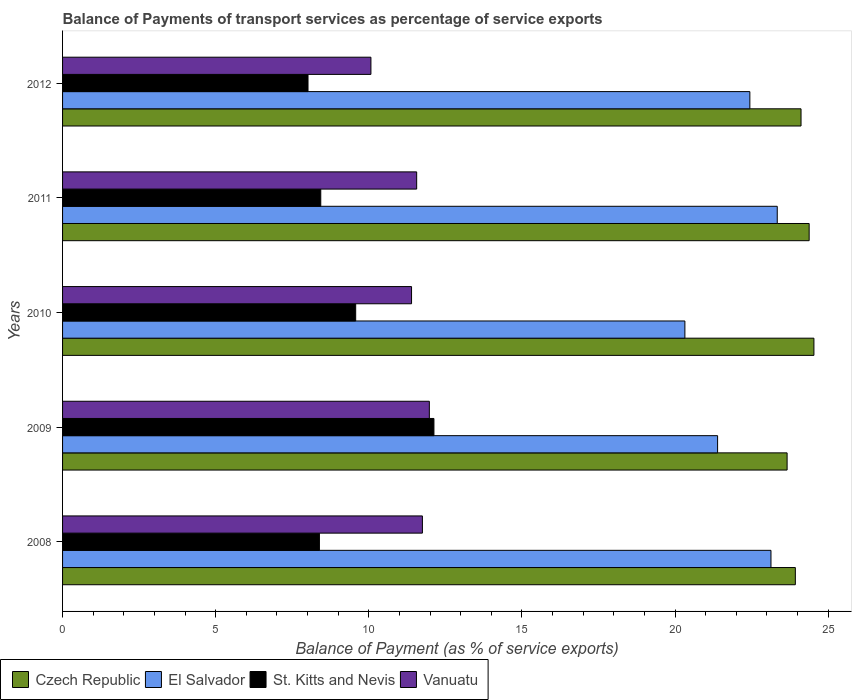How many different coloured bars are there?
Ensure brevity in your answer.  4. How many groups of bars are there?
Provide a short and direct response. 5. Are the number of bars per tick equal to the number of legend labels?
Your answer should be compact. Yes. How many bars are there on the 5th tick from the top?
Your answer should be very brief. 4. How many bars are there on the 1st tick from the bottom?
Provide a short and direct response. 4. In how many cases, is the number of bars for a given year not equal to the number of legend labels?
Provide a succinct answer. 0. What is the balance of payments of transport services in Czech Republic in 2011?
Your answer should be very brief. 24.38. Across all years, what is the maximum balance of payments of transport services in St. Kitts and Nevis?
Offer a terse response. 12.13. Across all years, what is the minimum balance of payments of transport services in Vanuatu?
Your answer should be compact. 10.07. In which year was the balance of payments of transport services in Vanuatu maximum?
Provide a succinct answer. 2009. In which year was the balance of payments of transport services in Czech Republic minimum?
Offer a very short reply. 2009. What is the total balance of payments of transport services in Vanuatu in the graph?
Keep it short and to the point. 56.76. What is the difference between the balance of payments of transport services in El Salvador in 2010 and that in 2012?
Provide a succinct answer. -2.12. What is the difference between the balance of payments of transport services in St. Kitts and Nevis in 2010 and the balance of payments of transport services in Czech Republic in 2012?
Keep it short and to the point. -14.54. What is the average balance of payments of transport services in Vanuatu per year?
Provide a short and direct response. 11.35. In the year 2008, what is the difference between the balance of payments of transport services in El Salvador and balance of payments of transport services in Czech Republic?
Provide a short and direct response. -0.8. What is the ratio of the balance of payments of transport services in St. Kitts and Nevis in 2009 to that in 2012?
Give a very brief answer. 1.51. What is the difference between the highest and the second highest balance of payments of transport services in St. Kitts and Nevis?
Keep it short and to the point. 2.56. What is the difference between the highest and the lowest balance of payments of transport services in Vanuatu?
Make the answer very short. 1.91. Is the sum of the balance of payments of transport services in El Salvador in 2009 and 2011 greater than the maximum balance of payments of transport services in St. Kitts and Nevis across all years?
Provide a short and direct response. Yes. Is it the case that in every year, the sum of the balance of payments of transport services in Czech Republic and balance of payments of transport services in Vanuatu is greater than the sum of balance of payments of transport services in St. Kitts and Nevis and balance of payments of transport services in El Salvador?
Provide a succinct answer. No. What does the 4th bar from the top in 2011 represents?
Your answer should be compact. Czech Republic. What does the 3rd bar from the bottom in 2008 represents?
Offer a terse response. St. Kitts and Nevis. How many bars are there?
Give a very brief answer. 20. Are all the bars in the graph horizontal?
Offer a terse response. Yes. Are the values on the major ticks of X-axis written in scientific E-notation?
Provide a succinct answer. No. Does the graph contain grids?
Provide a short and direct response. No. How many legend labels are there?
Provide a short and direct response. 4. What is the title of the graph?
Your response must be concise. Balance of Payments of transport services as percentage of service exports. Does "Mauritius" appear as one of the legend labels in the graph?
Keep it short and to the point. No. What is the label or title of the X-axis?
Provide a short and direct response. Balance of Payment (as % of service exports). What is the label or title of the Y-axis?
Provide a succinct answer. Years. What is the Balance of Payment (as % of service exports) in Czech Republic in 2008?
Give a very brief answer. 23.93. What is the Balance of Payment (as % of service exports) in El Salvador in 2008?
Offer a terse response. 23.13. What is the Balance of Payment (as % of service exports) in St. Kitts and Nevis in 2008?
Offer a very short reply. 8.39. What is the Balance of Payment (as % of service exports) of Vanuatu in 2008?
Provide a succinct answer. 11.75. What is the Balance of Payment (as % of service exports) of Czech Republic in 2009?
Offer a terse response. 23.66. What is the Balance of Payment (as % of service exports) in El Salvador in 2009?
Keep it short and to the point. 21.39. What is the Balance of Payment (as % of service exports) of St. Kitts and Nevis in 2009?
Provide a short and direct response. 12.13. What is the Balance of Payment (as % of service exports) of Vanuatu in 2009?
Make the answer very short. 11.98. What is the Balance of Payment (as % of service exports) in Czech Republic in 2010?
Your answer should be very brief. 24.54. What is the Balance of Payment (as % of service exports) in El Salvador in 2010?
Your response must be concise. 20.32. What is the Balance of Payment (as % of service exports) in St. Kitts and Nevis in 2010?
Keep it short and to the point. 9.57. What is the Balance of Payment (as % of service exports) of Vanuatu in 2010?
Keep it short and to the point. 11.4. What is the Balance of Payment (as % of service exports) in Czech Republic in 2011?
Keep it short and to the point. 24.38. What is the Balance of Payment (as % of service exports) of El Salvador in 2011?
Make the answer very short. 23.34. What is the Balance of Payment (as % of service exports) of St. Kitts and Nevis in 2011?
Provide a short and direct response. 8.43. What is the Balance of Payment (as % of service exports) of Vanuatu in 2011?
Keep it short and to the point. 11.56. What is the Balance of Payment (as % of service exports) of Czech Republic in 2012?
Offer a terse response. 24.12. What is the Balance of Payment (as % of service exports) in El Salvador in 2012?
Ensure brevity in your answer.  22.44. What is the Balance of Payment (as % of service exports) in St. Kitts and Nevis in 2012?
Provide a short and direct response. 8.02. What is the Balance of Payment (as % of service exports) of Vanuatu in 2012?
Offer a very short reply. 10.07. Across all years, what is the maximum Balance of Payment (as % of service exports) of Czech Republic?
Give a very brief answer. 24.54. Across all years, what is the maximum Balance of Payment (as % of service exports) of El Salvador?
Offer a very short reply. 23.34. Across all years, what is the maximum Balance of Payment (as % of service exports) in St. Kitts and Nevis?
Your answer should be very brief. 12.13. Across all years, what is the maximum Balance of Payment (as % of service exports) in Vanuatu?
Offer a terse response. 11.98. Across all years, what is the minimum Balance of Payment (as % of service exports) in Czech Republic?
Offer a very short reply. 23.66. Across all years, what is the minimum Balance of Payment (as % of service exports) in El Salvador?
Your answer should be very brief. 20.32. Across all years, what is the minimum Balance of Payment (as % of service exports) of St. Kitts and Nevis?
Your response must be concise. 8.02. Across all years, what is the minimum Balance of Payment (as % of service exports) in Vanuatu?
Your answer should be very brief. 10.07. What is the total Balance of Payment (as % of service exports) in Czech Republic in the graph?
Keep it short and to the point. 120.62. What is the total Balance of Payment (as % of service exports) of El Salvador in the graph?
Ensure brevity in your answer.  110.63. What is the total Balance of Payment (as % of service exports) of St. Kitts and Nevis in the graph?
Offer a very short reply. 46.53. What is the total Balance of Payment (as % of service exports) of Vanuatu in the graph?
Give a very brief answer. 56.76. What is the difference between the Balance of Payment (as % of service exports) in Czech Republic in 2008 and that in 2009?
Offer a terse response. 0.27. What is the difference between the Balance of Payment (as % of service exports) of El Salvador in 2008 and that in 2009?
Your answer should be compact. 1.74. What is the difference between the Balance of Payment (as % of service exports) in St. Kitts and Nevis in 2008 and that in 2009?
Your response must be concise. -3.74. What is the difference between the Balance of Payment (as % of service exports) of Vanuatu in 2008 and that in 2009?
Offer a terse response. -0.23. What is the difference between the Balance of Payment (as % of service exports) of Czech Republic in 2008 and that in 2010?
Keep it short and to the point. -0.61. What is the difference between the Balance of Payment (as % of service exports) of El Salvador in 2008 and that in 2010?
Keep it short and to the point. 2.81. What is the difference between the Balance of Payment (as % of service exports) in St. Kitts and Nevis in 2008 and that in 2010?
Give a very brief answer. -1.18. What is the difference between the Balance of Payment (as % of service exports) in Vanuatu in 2008 and that in 2010?
Your response must be concise. 0.35. What is the difference between the Balance of Payment (as % of service exports) in Czech Republic in 2008 and that in 2011?
Give a very brief answer. -0.45. What is the difference between the Balance of Payment (as % of service exports) of El Salvador in 2008 and that in 2011?
Ensure brevity in your answer.  -0.2. What is the difference between the Balance of Payment (as % of service exports) of St. Kitts and Nevis in 2008 and that in 2011?
Offer a terse response. -0.04. What is the difference between the Balance of Payment (as % of service exports) of Vanuatu in 2008 and that in 2011?
Your answer should be compact. 0.19. What is the difference between the Balance of Payment (as % of service exports) in Czech Republic in 2008 and that in 2012?
Ensure brevity in your answer.  -0.19. What is the difference between the Balance of Payment (as % of service exports) of El Salvador in 2008 and that in 2012?
Keep it short and to the point. 0.69. What is the difference between the Balance of Payment (as % of service exports) of St. Kitts and Nevis in 2008 and that in 2012?
Make the answer very short. 0.37. What is the difference between the Balance of Payment (as % of service exports) in Vanuatu in 2008 and that in 2012?
Offer a very short reply. 1.68. What is the difference between the Balance of Payment (as % of service exports) in Czech Republic in 2009 and that in 2010?
Your answer should be compact. -0.88. What is the difference between the Balance of Payment (as % of service exports) in El Salvador in 2009 and that in 2010?
Provide a short and direct response. 1.07. What is the difference between the Balance of Payment (as % of service exports) of St. Kitts and Nevis in 2009 and that in 2010?
Provide a short and direct response. 2.56. What is the difference between the Balance of Payment (as % of service exports) in Vanuatu in 2009 and that in 2010?
Give a very brief answer. 0.58. What is the difference between the Balance of Payment (as % of service exports) of Czech Republic in 2009 and that in 2011?
Offer a terse response. -0.72. What is the difference between the Balance of Payment (as % of service exports) in El Salvador in 2009 and that in 2011?
Ensure brevity in your answer.  -1.95. What is the difference between the Balance of Payment (as % of service exports) of St. Kitts and Nevis in 2009 and that in 2011?
Provide a succinct answer. 3.7. What is the difference between the Balance of Payment (as % of service exports) of Vanuatu in 2009 and that in 2011?
Offer a terse response. 0.41. What is the difference between the Balance of Payment (as % of service exports) of Czech Republic in 2009 and that in 2012?
Your response must be concise. -0.45. What is the difference between the Balance of Payment (as % of service exports) of El Salvador in 2009 and that in 2012?
Offer a terse response. -1.05. What is the difference between the Balance of Payment (as % of service exports) of St. Kitts and Nevis in 2009 and that in 2012?
Provide a short and direct response. 4.11. What is the difference between the Balance of Payment (as % of service exports) of Vanuatu in 2009 and that in 2012?
Provide a short and direct response. 1.91. What is the difference between the Balance of Payment (as % of service exports) in Czech Republic in 2010 and that in 2011?
Offer a terse response. 0.16. What is the difference between the Balance of Payment (as % of service exports) of El Salvador in 2010 and that in 2011?
Keep it short and to the point. -3.02. What is the difference between the Balance of Payment (as % of service exports) in St. Kitts and Nevis in 2010 and that in 2011?
Give a very brief answer. 1.14. What is the difference between the Balance of Payment (as % of service exports) in Vanuatu in 2010 and that in 2011?
Provide a short and direct response. -0.17. What is the difference between the Balance of Payment (as % of service exports) in Czech Republic in 2010 and that in 2012?
Provide a short and direct response. 0.42. What is the difference between the Balance of Payment (as % of service exports) of El Salvador in 2010 and that in 2012?
Keep it short and to the point. -2.12. What is the difference between the Balance of Payment (as % of service exports) of St. Kitts and Nevis in 2010 and that in 2012?
Your answer should be very brief. 1.56. What is the difference between the Balance of Payment (as % of service exports) in Vanuatu in 2010 and that in 2012?
Give a very brief answer. 1.33. What is the difference between the Balance of Payment (as % of service exports) in Czech Republic in 2011 and that in 2012?
Your response must be concise. 0.27. What is the difference between the Balance of Payment (as % of service exports) in El Salvador in 2011 and that in 2012?
Your answer should be compact. 0.89. What is the difference between the Balance of Payment (as % of service exports) in St. Kitts and Nevis in 2011 and that in 2012?
Your response must be concise. 0.42. What is the difference between the Balance of Payment (as % of service exports) of Vanuatu in 2011 and that in 2012?
Your response must be concise. 1.49. What is the difference between the Balance of Payment (as % of service exports) in Czech Republic in 2008 and the Balance of Payment (as % of service exports) in El Salvador in 2009?
Your response must be concise. 2.54. What is the difference between the Balance of Payment (as % of service exports) in Czech Republic in 2008 and the Balance of Payment (as % of service exports) in St. Kitts and Nevis in 2009?
Offer a very short reply. 11.8. What is the difference between the Balance of Payment (as % of service exports) of Czech Republic in 2008 and the Balance of Payment (as % of service exports) of Vanuatu in 2009?
Offer a very short reply. 11.95. What is the difference between the Balance of Payment (as % of service exports) in El Salvador in 2008 and the Balance of Payment (as % of service exports) in St. Kitts and Nevis in 2009?
Give a very brief answer. 11.01. What is the difference between the Balance of Payment (as % of service exports) in El Salvador in 2008 and the Balance of Payment (as % of service exports) in Vanuatu in 2009?
Offer a very short reply. 11.16. What is the difference between the Balance of Payment (as % of service exports) of St. Kitts and Nevis in 2008 and the Balance of Payment (as % of service exports) of Vanuatu in 2009?
Offer a very short reply. -3.59. What is the difference between the Balance of Payment (as % of service exports) of Czech Republic in 2008 and the Balance of Payment (as % of service exports) of El Salvador in 2010?
Offer a very short reply. 3.61. What is the difference between the Balance of Payment (as % of service exports) of Czech Republic in 2008 and the Balance of Payment (as % of service exports) of St. Kitts and Nevis in 2010?
Provide a succinct answer. 14.36. What is the difference between the Balance of Payment (as % of service exports) in Czech Republic in 2008 and the Balance of Payment (as % of service exports) in Vanuatu in 2010?
Offer a terse response. 12.53. What is the difference between the Balance of Payment (as % of service exports) of El Salvador in 2008 and the Balance of Payment (as % of service exports) of St. Kitts and Nevis in 2010?
Give a very brief answer. 13.56. What is the difference between the Balance of Payment (as % of service exports) in El Salvador in 2008 and the Balance of Payment (as % of service exports) in Vanuatu in 2010?
Make the answer very short. 11.74. What is the difference between the Balance of Payment (as % of service exports) of St. Kitts and Nevis in 2008 and the Balance of Payment (as % of service exports) of Vanuatu in 2010?
Keep it short and to the point. -3.01. What is the difference between the Balance of Payment (as % of service exports) in Czech Republic in 2008 and the Balance of Payment (as % of service exports) in El Salvador in 2011?
Offer a very short reply. 0.59. What is the difference between the Balance of Payment (as % of service exports) in Czech Republic in 2008 and the Balance of Payment (as % of service exports) in St. Kitts and Nevis in 2011?
Give a very brief answer. 15.5. What is the difference between the Balance of Payment (as % of service exports) of Czech Republic in 2008 and the Balance of Payment (as % of service exports) of Vanuatu in 2011?
Provide a short and direct response. 12.37. What is the difference between the Balance of Payment (as % of service exports) in El Salvador in 2008 and the Balance of Payment (as % of service exports) in St. Kitts and Nevis in 2011?
Keep it short and to the point. 14.7. What is the difference between the Balance of Payment (as % of service exports) of El Salvador in 2008 and the Balance of Payment (as % of service exports) of Vanuatu in 2011?
Give a very brief answer. 11.57. What is the difference between the Balance of Payment (as % of service exports) of St. Kitts and Nevis in 2008 and the Balance of Payment (as % of service exports) of Vanuatu in 2011?
Your answer should be compact. -3.18. What is the difference between the Balance of Payment (as % of service exports) of Czech Republic in 2008 and the Balance of Payment (as % of service exports) of El Salvador in 2012?
Your response must be concise. 1.49. What is the difference between the Balance of Payment (as % of service exports) in Czech Republic in 2008 and the Balance of Payment (as % of service exports) in St. Kitts and Nevis in 2012?
Your response must be concise. 15.91. What is the difference between the Balance of Payment (as % of service exports) in Czech Republic in 2008 and the Balance of Payment (as % of service exports) in Vanuatu in 2012?
Keep it short and to the point. 13.86. What is the difference between the Balance of Payment (as % of service exports) in El Salvador in 2008 and the Balance of Payment (as % of service exports) in St. Kitts and Nevis in 2012?
Offer a very short reply. 15.12. What is the difference between the Balance of Payment (as % of service exports) in El Salvador in 2008 and the Balance of Payment (as % of service exports) in Vanuatu in 2012?
Keep it short and to the point. 13.06. What is the difference between the Balance of Payment (as % of service exports) in St. Kitts and Nevis in 2008 and the Balance of Payment (as % of service exports) in Vanuatu in 2012?
Ensure brevity in your answer.  -1.68. What is the difference between the Balance of Payment (as % of service exports) of Czech Republic in 2009 and the Balance of Payment (as % of service exports) of El Salvador in 2010?
Keep it short and to the point. 3.34. What is the difference between the Balance of Payment (as % of service exports) of Czech Republic in 2009 and the Balance of Payment (as % of service exports) of St. Kitts and Nevis in 2010?
Your response must be concise. 14.09. What is the difference between the Balance of Payment (as % of service exports) of Czech Republic in 2009 and the Balance of Payment (as % of service exports) of Vanuatu in 2010?
Provide a succinct answer. 12.26. What is the difference between the Balance of Payment (as % of service exports) of El Salvador in 2009 and the Balance of Payment (as % of service exports) of St. Kitts and Nevis in 2010?
Ensure brevity in your answer.  11.82. What is the difference between the Balance of Payment (as % of service exports) in El Salvador in 2009 and the Balance of Payment (as % of service exports) in Vanuatu in 2010?
Provide a succinct answer. 9.99. What is the difference between the Balance of Payment (as % of service exports) of St. Kitts and Nevis in 2009 and the Balance of Payment (as % of service exports) of Vanuatu in 2010?
Your answer should be compact. 0.73. What is the difference between the Balance of Payment (as % of service exports) in Czech Republic in 2009 and the Balance of Payment (as % of service exports) in El Salvador in 2011?
Your response must be concise. 0.32. What is the difference between the Balance of Payment (as % of service exports) in Czech Republic in 2009 and the Balance of Payment (as % of service exports) in St. Kitts and Nevis in 2011?
Provide a short and direct response. 15.23. What is the difference between the Balance of Payment (as % of service exports) in Czech Republic in 2009 and the Balance of Payment (as % of service exports) in Vanuatu in 2011?
Make the answer very short. 12.1. What is the difference between the Balance of Payment (as % of service exports) in El Salvador in 2009 and the Balance of Payment (as % of service exports) in St. Kitts and Nevis in 2011?
Provide a succinct answer. 12.96. What is the difference between the Balance of Payment (as % of service exports) of El Salvador in 2009 and the Balance of Payment (as % of service exports) of Vanuatu in 2011?
Make the answer very short. 9.83. What is the difference between the Balance of Payment (as % of service exports) in St. Kitts and Nevis in 2009 and the Balance of Payment (as % of service exports) in Vanuatu in 2011?
Ensure brevity in your answer.  0.56. What is the difference between the Balance of Payment (as % of service exports) of Czech Republic in 2009 and the Balance of Payment (as % of service exports) of El Salvador in 2012?
Give a very brief answer. 1.22. What is the difference between the Balance of Payment (as % of service exports) of Czech Republic in 2009 and the Balance of Payment (as % of service exports) of St. Kitts and Nevis in 2012?
Your answer should be compact. 15.65. What is the difference between the Balance of Payment (as % of service exports) of Czech Republic in 2009 and the Balance of Payment (as % of service exports) of Vanuatu in 2012?
Provide a short and direct response. 13.59. What is the difference between the Balance of Payment (as % of service exports) in El Salvador in 2009 and the Balance of Payment (as % of service exports) in St. Kitts and Nevis in 2012?
Your answer should be very brief. 13.38. What is the difference between the Balance of Payment (as % of service exports) in El Salvador in 2009 and the Balance of Payment (as % of service exports) in Vanuatu in 2012?
Give a very brief answer. 11.32. What is the difference between the Balance of Payment (as % of service exports) in St. Kitts and Nevis in 2009 and the Balance of Payment (as % of service exports) in Vanuatu in 2012?
Give a very brief answer. 2.06. What is the difference between the Balance of Payment (as % of service exports) of Czech Republic in 2010 and the Balance of Payment (as % of service exports) of El Salvador in 2011?
Your answer should be very brief. 1.2. What is the difference between the Balance of Payment (as % of service exports) in Czech Republic in 2010 and the Balance of Payment (as % of service exports) in St. Kitts and Nevis in 2011?
Offer a very short reply. 16.1. What is the difference between the Balance of Payment (as % of service exports) in Czech Republic in 2010 and the Balance of Payment (as % of service exports) in Vanuatu in 2011?
Give a very brief answer. 12.97. What is the difference between the Balance of Payment (as % of service exports) of El Salvador in 2010 and the Balance of Payment (as % of service exports) of St. Kitts and Nevis in 2011?
Offer a very short reply. 11.89. What is the difference between the Balance of Payment (as % of service exports) of El Salvador in 2010 and the Balance of Payment (as % of service exports) of Vanuatu in 2011?
Your response must be concise. 8.76. What is the difference between the Balance of Payment (as % of service exports) in St. Kitts and Nevis in 2010 and the Balance of Payment (as % of service exports) in Vanuatu in 2011?
Provide a succinct answer. -1.99. What is the difference between the Balance of Payment (as % of service exports) in Czech Republic in 2010 and the Balance of Payment (as % of service exports) in El Salvador in 2012?
Give a very brief answer. 2.09. What is the difference between the Balance of Payment (as % of service exports) in Czech Republic in 2010 and the Balance of Payment (as % of service exports) in St. Kitts and Nevis in 2012?
Make the answer very short. 16.52. What is the difference between the Balance of Payment (as % of service exports) in Czech Republic in 2010 and the Balance of Payment (as % of service exports) in Vanuatu in 2012?
Give a very brief answer. 14.47. What is the difference between the Balance of Payment (as % of service exports) in El Salvador in 2010 and the Balance of Payment (as % of service exports) in St. Kitts and Nevis in 2012?
Offer a very short reply. 12.31. What is the difference between the Balance of Payment (as % of service exports) of El Salvador in 2010 and the Balance of Payment (as % of service exports) of Vanuatu in 2012?
Keep it short and to the point. 10.25. What is the difference between the Balance of Payment (as % of service exports) of St. Kitts and Nevis in 2010 and the Balance of Payment (as % of service exports) of Vanuatu in 2012?
Your answer should be very brief. -0.5. What is the difference between the Balance of Payment (as % of service exports) in Czech Republic in 2011 and the Balance of Payment (as % of service exports) in El Salvador in 2012?
Ensure brevity in your answer.  1.94. What is the difference between the Balance of Payment (as % of service exports) of Czech Republic in 2011 and the Balance of Payment (as % of service exports) of St. Kitts and Nevis in 2012?
Your answer should be compact. 16.37. What is the difference between the Balance of Payment (as % of service exports) of Czech Republic in 2011 and the Balance of Payment (as % of service exports) of Vanuatu in 2012?
Ensure brevity in your answer.  14.31. What is the difference between the Balance of Payment (as % of service exports) in El Salvador in 2011 and the Balance of Payment (as % of service exports) in St. Kitts and Nevis in 2012?
Offer a terse response. 15.32. What is the difference between the Balance of Payment (as % of service exports) in El Salvador in 2011 and the Balance of Payment (as % of service exports) in Vanuatu in 2012?
Make the answer very short. 13.27. What is the difference between the Balance of Payment (as % of service exports) in St. Kitts and Nevis in 2011 and the Balance of Payment (as % of service exports) in Vanuatu in 2012?
Offer a terse response. -1.64. What is the average Balance of Payment (as % of service exports) in Czech Republic per year?
Your answer should be very brief. 24.12. What is the average Balance of Payment (as % of service exports) in El Salvador per year?
Your answer should be compact. 22.13. What is the average Balance of Payment (as % of service exports) of St. Kitts and Nevis per year?
Offer a very short reply. 9.31. What is the average Balance of Payment (as % of service exports) in Vanuatu per year?
Ensure brevity in your answer.  11.35. In the year 2008, what is the difference between the Balance of Payment (as % of service exports) in Czech Republic and Balance of Payment (as % of service exports) in El Salvador?
Your answer should be compact. 0.8. In the year 2008, what is the difference between the Balance of Payment (as % of service exports) in Czech Republic and Balance of Payment (as % of service exports) in St. Kitts and Nevis?
Offer a terse response. 15.54. In the year 2008, what is the difference between the Balance of Payment (as % of service exports) of Czech Republic and Balance of Payment (as % of service exports) of Vanuatu?
Give a very brief answer. 12.18. In the year 2008, what is the difference between the Balance of Payment (as % of service exports) of El Salvador and Balance of Payment (as % of service exports) of St. Kitts and Nevis?
Provide a succinct answer. 14.75. In the year 2008, what is the difference between the Balance of Payment (as % of service exports) of El Salvador and Balance of Payment (as % of service exports) of Vanuatu?
Your answer should be very brief. 11.38. In the year 2008, what is the difference between the Balance of Payment (as % of service exports) of St. Kitts and Nevis and Balance of Payment (as % of service exports) of Vanuatu?
Your answer should be very brief. -3.36. In the year 2009, what is the difference between the Balance of Payment (as % of service exports) of Czech Republic and Balance of Payment (as % of service exports) of El Salvador?
Your answer should be very brief. 2.27. In the year 2009, what is the difference between the Balance of Payment (as % of service exports) in Czech Republic and Balance of Payment (as % of service exports) in St. Kitts and Nevis?
Give a very brief answer. 11.53. In the year 2009, what is the difference between the Balance of Payment (as % of service exports) in Czech Republic and Balance of Payment (as % of service exports) in Vanuatu?
Your response must be concise. 11.68. In the year 2009, what is the difference between the Balance of Payment (as % of service exports) of El Salvador and Balance of Payment (as % of service exports) of St. Kitts and Nevis?
Keep it short and to the point. 9.26. In the year 2009, what is the difference between the Balance of Payment (as % of service exports) in El Salvador and Balance of Payment (as % of service exports) in Vanuatu?
Your response must be concise. 9.41. In the year 2009, what is the difference between the Balance of Payment (as % of service exports) of St. Kitts and Nevis and Balance of Payment (as % of service exports) of Vanuatu?
Offer a terse response. 0.15. In the year 2010, what is the difference between the Balance of Payment (as % of service exports) in Czech Republic and Balance of Payment (as % of service exports) in El Salvador?
Your response must be concise. 4.21. In the year 2010, what is the difference between the Balance of Payment (as % of service exports) in Czech Republic and Balance of Payment (as % of service exports) in St. Kitts and Nevis?
Your answer should be compact. 14.96. In the year 2010, what is the difference between the Balance of Payment (as % of service exports) of Czech Republic and Balance of Payment (as % of service exports) of Vanuatu?
Ensure brevity in your answer.  13.14. In the year 2010, what is the difference between the Balance of Payment (as % of service exports) of El Salvador and Balance of Payment (as % of service exports) of St. Kitts and Nevis?
Provide a succinct answer. 10.75. In the year 2010, what is the difference between the Balance of Payment (as % of service exports) of El Salvador and Balance of Payment (as % of service exports) of Vanuatu?
Provide a short and direct response. 8.93. In the year 2010, what is the difference between the Balance of Payment (as % of service exports) in St. Kitts and Nevis and Balance of Payment (as % of service exports) in Vanuatu?
Provide a succinct answer. -1.82. In the year 2011, what is the difference between the Balance of Payment (as % of service exports) in Czech Republic and Balance of Payment (as % of service exports) in El Salvador?
Your response must be concise. 1.04. In the year 2011, what is the difference between the Balance of Payment (as % of service exports) of Czech Republic and Balance of Payment (as % of service exports) of St. Kitts and Nevis?
Your response must be concise. 15.95. In the year 2011, what is the difference between the Balance of Payment (as % of service exports) of Czech Republic and Balance of Payment (as % of service exports) of Vanuatu?
Ensure brevity in your answer.  12.82. In the year 2011, what is the difference between the Balance of Payment (as % of service exports) of El Salvador and Balance of Payment (as % of service exports) of St. Kitts and Nevis?
Offer a terse response. 14.91. In the year 2011, what is the difference between the Balance of Payment (as % of service exports) in El Salvador and Balance of Payment (as % of service exports) in Vanuatu?
Give a very brief answer. 11.78. In the year 2011, what is the difference between the Balance of Payment (as % of service exports) in St. Kitts and Nevis and Balance of Payment (as % of service exports) in Vanuatu?
Ensure brevity in your answer.  -3.13. In the year 2012, what is the difference between the Balance of Payment (as % of service exports) in Czech Republic and Balance of Payment (as % of service exports) in El Salvador?
Give a very brief answer. 1.67. In the year 2012, what is the difference between the Balance of Payment (as % of service exports) in Czech Republic and Balance of Payment (as % of service exports) in Vanuatu?
Provide a short and direct response. 14.05. In the year 2012, what is the difference between the Balance of Payment (as % of service exports) in El Salvador and Balance of Payment (as % of service exports) in St. Kitts and Nevis?
Give a very brief answer. 14.43. In the year 2012, what is the difference between the Balance of Payment (as % of service exports) in El Salvador and Balance of Payment (as % of service exports) in Vanuatu?
Provide a short and direct response. 12.37. In the year 2012, what is the difference between the Balance of Payment (as % of service exports) in St. Kitts and Nevis and Balance of Payment (as % of service exports) in Vanuatu?
Provide a succinct answer. -2.05. What is the ratio of the Balance of Payment (as % of service exports) in Czech Republic in 2008 to that in 2009?
Provide a succinct answer. 1.01. What is the ratio of the Balance of Payment (as % of service exports) in El Salvador in 2008 to that in 2009?
Your response must be concise. 1.08. What is the ratio of the Balance of Payment (as % of service exports) of St. Kitts and Nevis in 2008 to that in 2009?
Your answer should be compact. 0.69. What is the ratio of the Balance of Payment (as % of service exports) in Vanuatu in 2008 to that in 2009?
Provide a succinct answer. 0.98. What is the ratio of the Balance of Payment (as % of service exports) of Czech Republic in 2008 to that in 2010?
Provide a short and direct response. 0.98. What is the ratio of the Balance of Payment (as % of service exports) in El Salvador in 2008 to that in 2010?
Offer a very short reply. 1.14. What is the ratio of the Balance of Payment (as % of service exports) of St. Kitts and Nevis in 2008 to that in 2010?
Provide a succinct answer. 0.88. What is the ratio of the Balance of Payment (as % of service exports) in Vanuatu in 2008 to that in 2010?
Provide a short and direct response. 1.03. What is the ratio of the Balance of Payment (as % of service exports) in Czech Republic in 2008 to that in 2011?
Ensure brevity in your answer.  0.98. What is the ratio of the Balance of Payment (as % of service exports) of El Salvador in 2008 to that in 2011?
Your response must be concise. 0.99. What is the ratio of the Balance of Payment (as % of service exports) of St. Kitts and Nevis in 2008 to that in 2011?
Ensure brevity in your answer.  0.99. What is the ratio of the Balance of Payment (as % of service exports) of Vanuatu in 2008 to that in 2011?
Your answer should be compact. 1.02. What is the ratio of the Balance of Payment (as % of service exports) in El Salvador in 2008 to that in 2012?
Your response must be concise. 1.03. What is the ratio of the Balance of Payment (as % of service exports) of St. Kitts and Nevis in 2008 to that in 2012?
Ensure brevity in your answer.  1.05. What is the ratio of the Balance of Payment (as % of service exports) in Vanuatu in 2008 to that in 2012?
Keep it short and to the point. 1.17. What is the ratio of the Balance of Payment (as % of service exports) in Czech Republic in 2009 to that in 2010?
Make the answer very short. 0.96. What is the ratio of the Balance of Payment (as % of service exports) of El Salvador in 2009 to that in 2010?
Provide a succinct answer. 1.05. What is the ratio of the Balance of Payment (as % of service exports) in St. Kitts and Nevis in 2009 to that in 2010?
Ensure brevity in your answer.  1.27. What is the ratio of the Balance of Payment (as % of service exports) in Vanuatu in 2009 to that in 2010?
Offer a terse response. 1.05. What is the ratio of the Balance of Payment (as % of service exports) in Czech Republic in 2009 to that in 2011?
Make the answer very short. 0.97. What is the ratio of the Balance of Payment (as % of service exports) of El Salvador in 2009 to that in 2011?
Give a very brief answer. 0.92. What is the ratio of the Balance of Payment (as % of service exports) in St. Kitts and Nevis in 2009 to that in 2011?
Offer a terse response. 1.44. What is the ratio of the Balance of Payment (as % of service exports) of Vanuatu in 2009 to that in 2011?
Your answer should be very brief. 1.04. What is the ratio of the Balance of Payment (as % of service exports) of Czech Republic in 2009 to that in 2012?
Your response must be concise. 0.98. What is the ratio of the Balance of Payment (as % of service exports) in El Salvador in 2009 to that in 2012?
Provide a short and direct response. 0.95. What is the ratio of the Balance of Payment (as % of service exports) in St. Kitts and Nevis in 2009 to that in 2012?
Provide a succinct answer. 1.51. What is the ratio of the Balance of Payment (as % of service exports) in Vanuatu in 2009 to that in 2012?
Your response must be concise. 1.19. What is the ratio of the Balance of Payment (as % of service exports) in Czech Republic in 2010 to that in 2011?
Ensure brevity in your answer.  1.01. What is the ratio of the Balance of Payment (as % of service exports) in El Salvador in 2010 to that in 2011?
Offer a terse response. 0.87. What is the ratio of the Balance of Payment (as % of service exports) of St. Kitts and Nevis in 2010 to that in 2011?
Give a very brief answer. 1.14. What is the ratio of the Balance of Payment (as % of service exports) in Vanuatu in 2010 to that in 2011?
Provide a succinct answer. 0.99. What is the ratio of the Balance of Payment (as % of service exports) of Czech Republic in 2010 to that in 2012?
Offer a terse response. 1.02. What is the ratio of the Balance of Payment (as % of service exports) of El Salvador in 2010 to that in 2012?
Offer a terse response. 0.91. What is the ratio of the Balance of Payment (as % of service exports) of St. Kitts and Nevis in 2010 to that in 2012?
Offer a terse response. 1.19. What is the ratio of the Balance of Payment (as % of service exports) in Vanuatu in 2010 to that in 2012?
Your response must be concise. 1.13. What is the ratio of the Balance of Payment (as % of service exports) of Czech Republic in 2011 to that in 2012?
Ensure brevity in your answer.  1.01. What is the ratio of the Balance of Payment (as % of service exports) in El Salvador in 2011 to that in 2012?
Keep it short and to the point. 1.04. What is the ratio of the Balance of Payment (as % of service exports) in St. Kitts and Nevis in 2011 to that in 2012?
Provide a short and direct response. 1.05. What is the ratio of the Balance of Payment (as % of service exports) of Vanuatu in 2011 to that in 2012?
Offer a very short reply. 1.15. What is the difference between the highest and the second highest Balance of Payment (as % of service exports) of Czech Republic?
Your response must be concise. 0.16. What is the difference between the highest and the second highest Balance of Payment (as % of service exports) of El Salvador?
Your answer should be very brief. 0.2. What is the difference between the highest and the second highest Balance of Payment (as % of service exports) of St. Kitts and Nevis?
Provide a succinct answer. 2.56. What is the difference between the highest and the second highest Balance of Payment (as % of service exports) of Vanuatu?
Ensure brevity in your answer.  0.23. What is the difference between the highest and the lowest Balance of Payment (as % of service exports) in Czech Republic?
Your response must be concise. 0.88. What is the difference between the highest and the lowest Balance of Payment (as % of service exports) in El Salvador?
Provide a succinct answer. 3.02. What is the difference between the highest and the lowest Balance of Payment (as % of service exports) in St. Kitts and Nevis?
Make the answer very short. 4.11. What is the difference between the highest and the lowest Balance of Payment (as % of service exports) in Vanuatu?
Your answer should be compact. 1.91. 